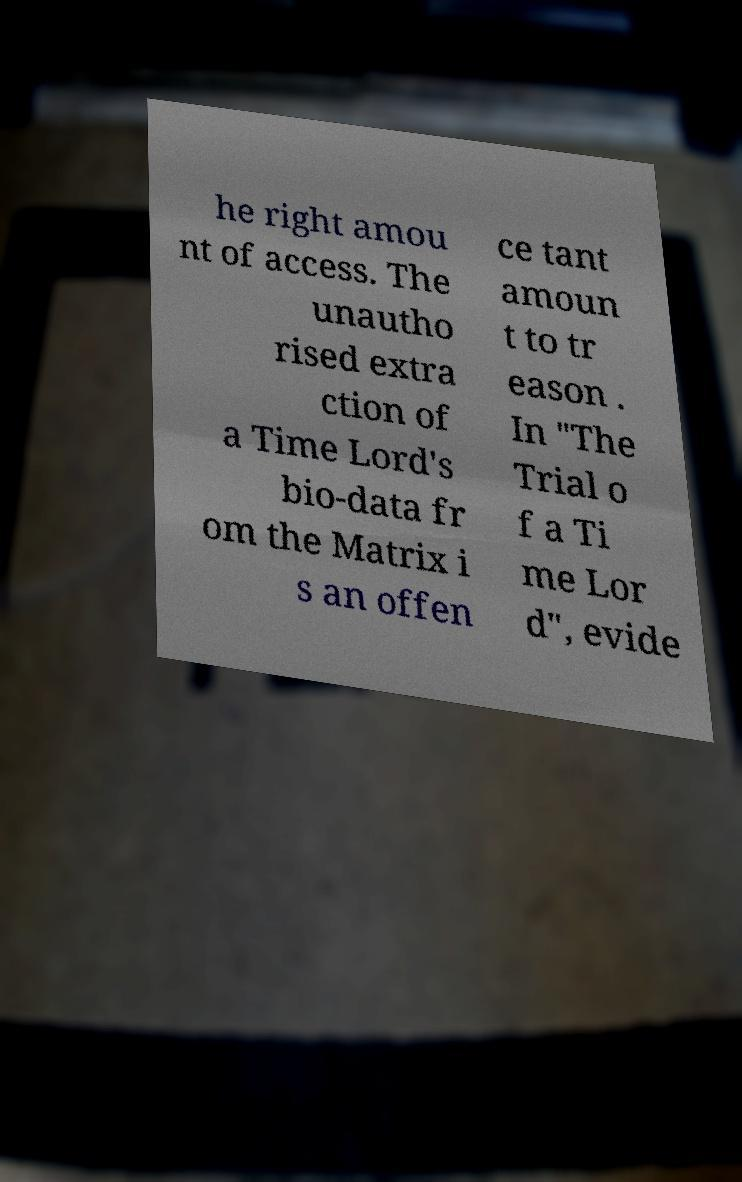For documentation purposes, I need the text within this image transcribed. Could you provide that? he right amou nt of access. The unautho rised extra ction of a Time Lord's bio-data fr om the Matrix i s an offen ce tant amoun t to tr eason . In "The Trial o f a Ti me Lor d", evide 